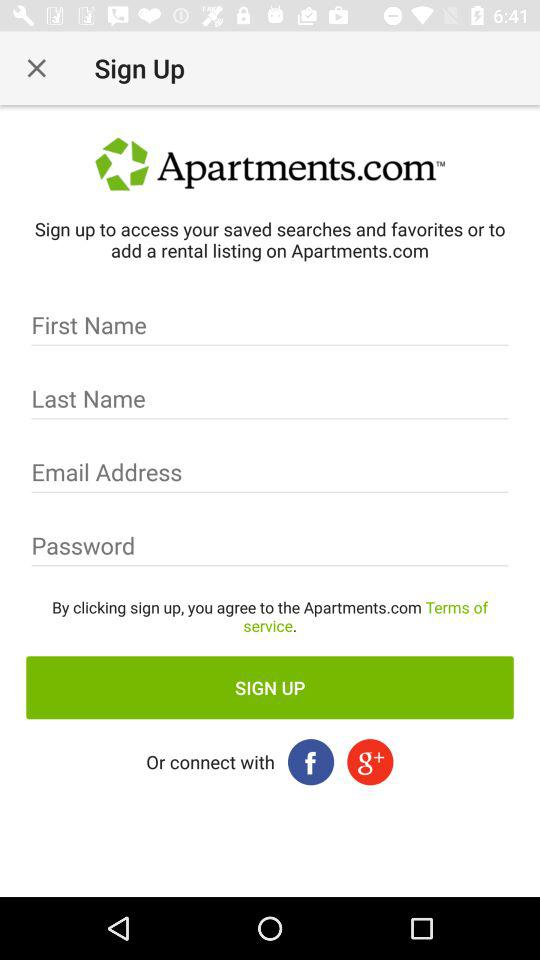How long must the password be?
When the provided information is insufficient, respond with <no answer>. <no answer> 